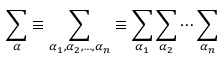Convert formula to latex. <formula><loc_0><loc_0><loc_500><loc_500>\sum _ { \alpha } \equiv \sum _ { \alpha _ { 1 } , \alpha _ { 2 } , \dots , \alpha _ { n } } \equiv \sum _ { \alpha _ { 1 } } \sum _ { \alpha _ { 2 } } \cdots \sum _ { \alpha _ { n } }</formula> 